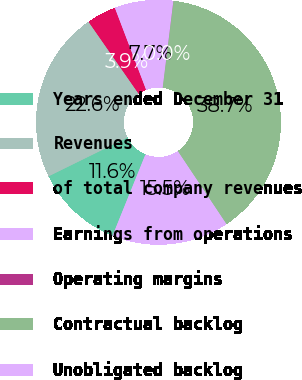<chart> <loc_0><loc_0><loc_500><loc_500><pie_chart><fcel>Years ended December 31<fcel>Revenues<fcel>of total company revenues<fcel>Earnings from operations<fcel>Operating margins<fcel>Contractual backlog<fcel>Unobligated backlog<nl><fcel>11.61%<fcel>22.6%<fcel>3.88%<fcel>7.75%<fcel>0.02%<fcel>38.67%<fcel>15.48%<nl></chart> 